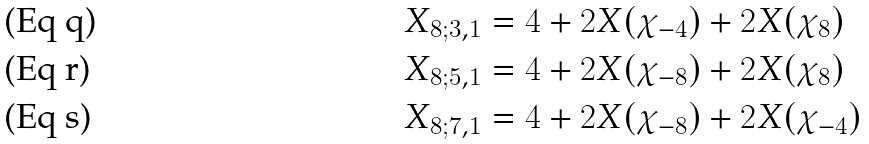Convert formula to latex. <formula><loc_0><loc_0><loc_500><loc_500>X _ { 8 ; 3 , 1 } & = 4 + 2 X ( \chi _ { - 4 } ) + 2 X ( \chi _ { 8 } ) \\ X _ { 8 ; 5 , 1 } & = 4 + 2 X ( \chi _ { - 8 } ) + 2 X ( \chi _ { 8 } ) \\ X _ { 8 ; 7 , 1 } & = 4 + 2 X ( \chi _ { - 8 } ) + 2 X ( \chi _ { - 4 } )</formula> 